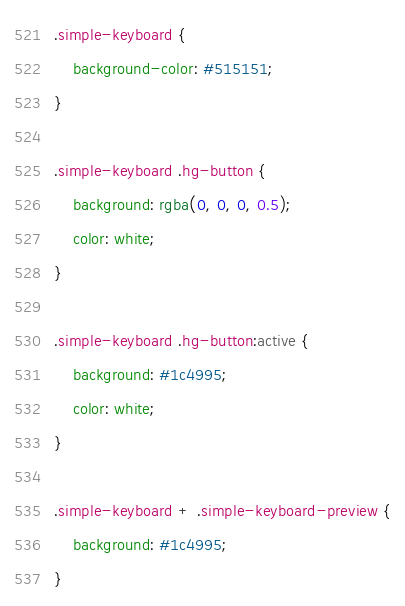Convert code to text. <code><loc_0><loc_0><loc_500><loc_500><_CSS_>.simple-keyboard {
    background-color: #515151;
}

.simple-keyboard .hg-button {
    background: rgba(0, 0, 0, 0.5);
    color: white;
}

.simple-keyboard .hg-button:active {
    background: #1c4995;
    color: white;
}

.simple-keyboard + .simple-keyboard-preview {
    background: #1c4995;
}</code> 